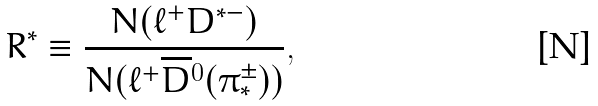<formula> <loc_0><loc_0><loc_500><loc_500>R ^ { * } \equiv \frac { N ( \ell ^ { + } D ^ { * - } ) } { N ( \ell ^ { + } \overline { D } { ^ { 0 } } ( \pi _ { * } ^ { \pm } ) ) } ,</formula> 